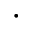Convert formula to latex. <formula><loc_0><loc_0><loc_500><loc_500>\cdot</formula> 